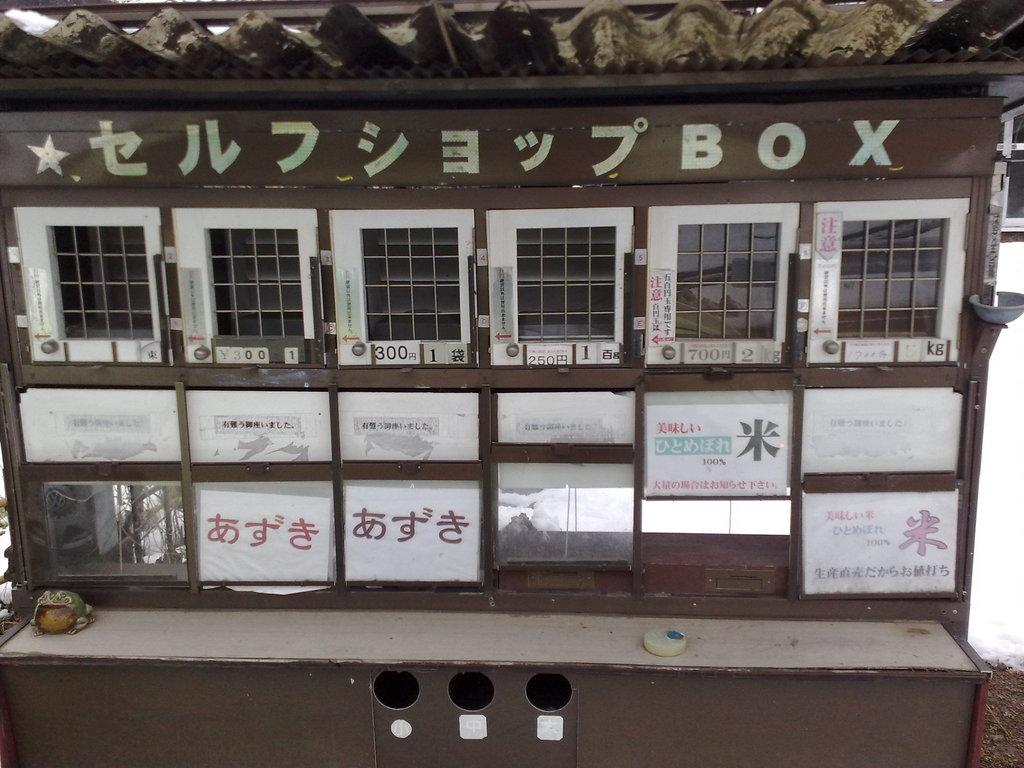How many kilograms is the item second from the right?
Your response must be concise. 2. 